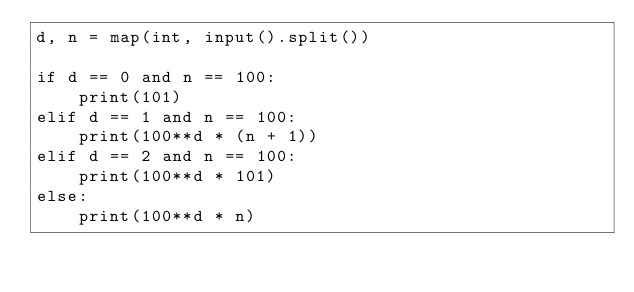Convert code to text. <code><loc_0><loc_0><loc_500><loc_500><_Python_>d, n = map(int, input().split())

if d == 0 and n == 100:
    print(101)
elif d == 1 and n == 100:
    print(100**d * (n + 1))
elif d == 2 and n == 100:
    print(100**d * 101)
else:
    print(100**d * n)</code> 